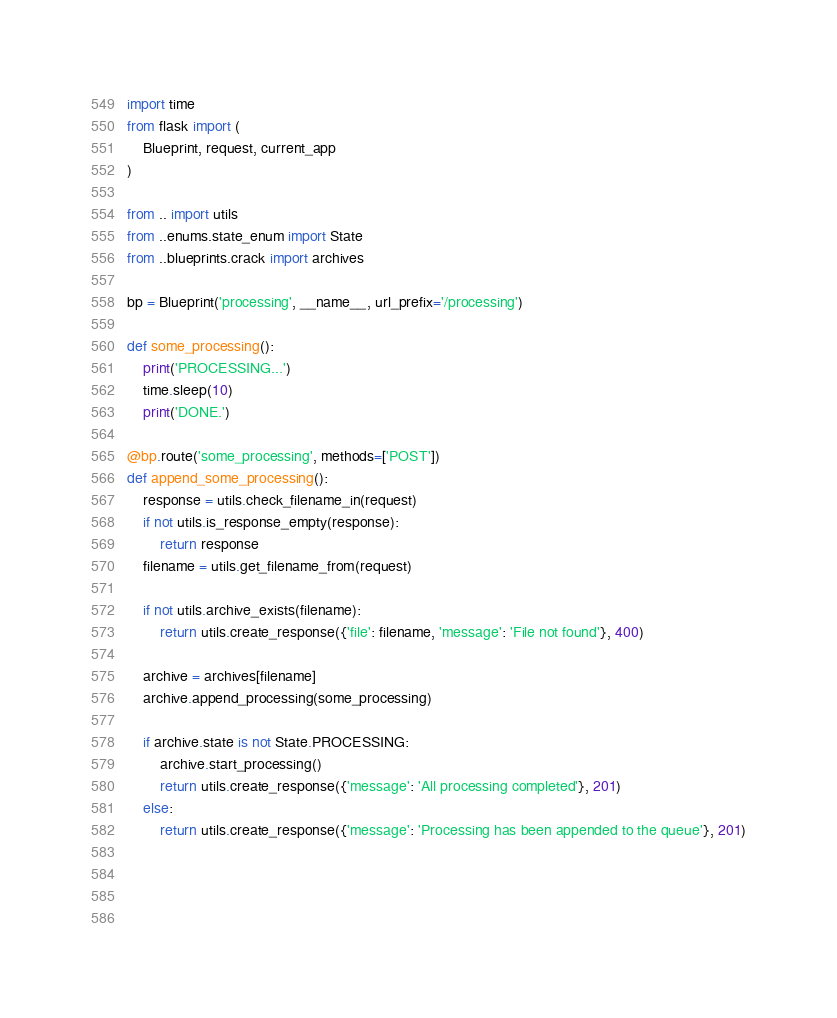Convert code to text. <code><loc_0><loc_0><loc_500><loc_500><_Python_>import time
from flask import (
    Blueprint, request, current_app
)

from .. import utils
from ..enums.state_enum import State
from ..blueprints.crack import archives

bp = Blueprint('processing', __name__, url_prefix='/processing')

def some_processing():
    print('PROCESSING...')
    time.sleep(10)
    print('DONE.')

@bp.route('some_processing', methods=['POST'])
def append_some_processing():
    response = utils.check_filename_in(request)
    if not utils.is_response_empty(response):
        return response
    filename = utils.get_filename_from(request)
        
    if not utils.archive_exists(filename):
        return utils.create_response({'file': filename, 'message': 'File not found'}, 400)

    archive = archives[filename]
    archive.append_processing(some_processing)

    if archive.state is not State.PROCESSING:
        archive.start_processing()
        return utils.create_response({'message': 'All processing completed'}, 201)
    else:
        return utils.create_response({'message': 'Processing has been appended to the queue'}, 201)

    

    </code> 